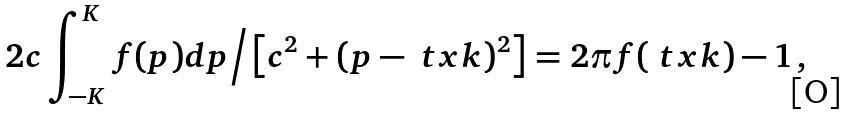Convert formula to latex. <formula><loc_0><loc_0><loc_500><loc_500>2 c \int _ { - K } ^ { K } f ( p ) d p \Big / \left [ c ^ { 2 } + ( p - \ t x k ) ^ { 2 } \right ] = 2 \pi f ( \ t x k ) - 1 \, ,</formula> 